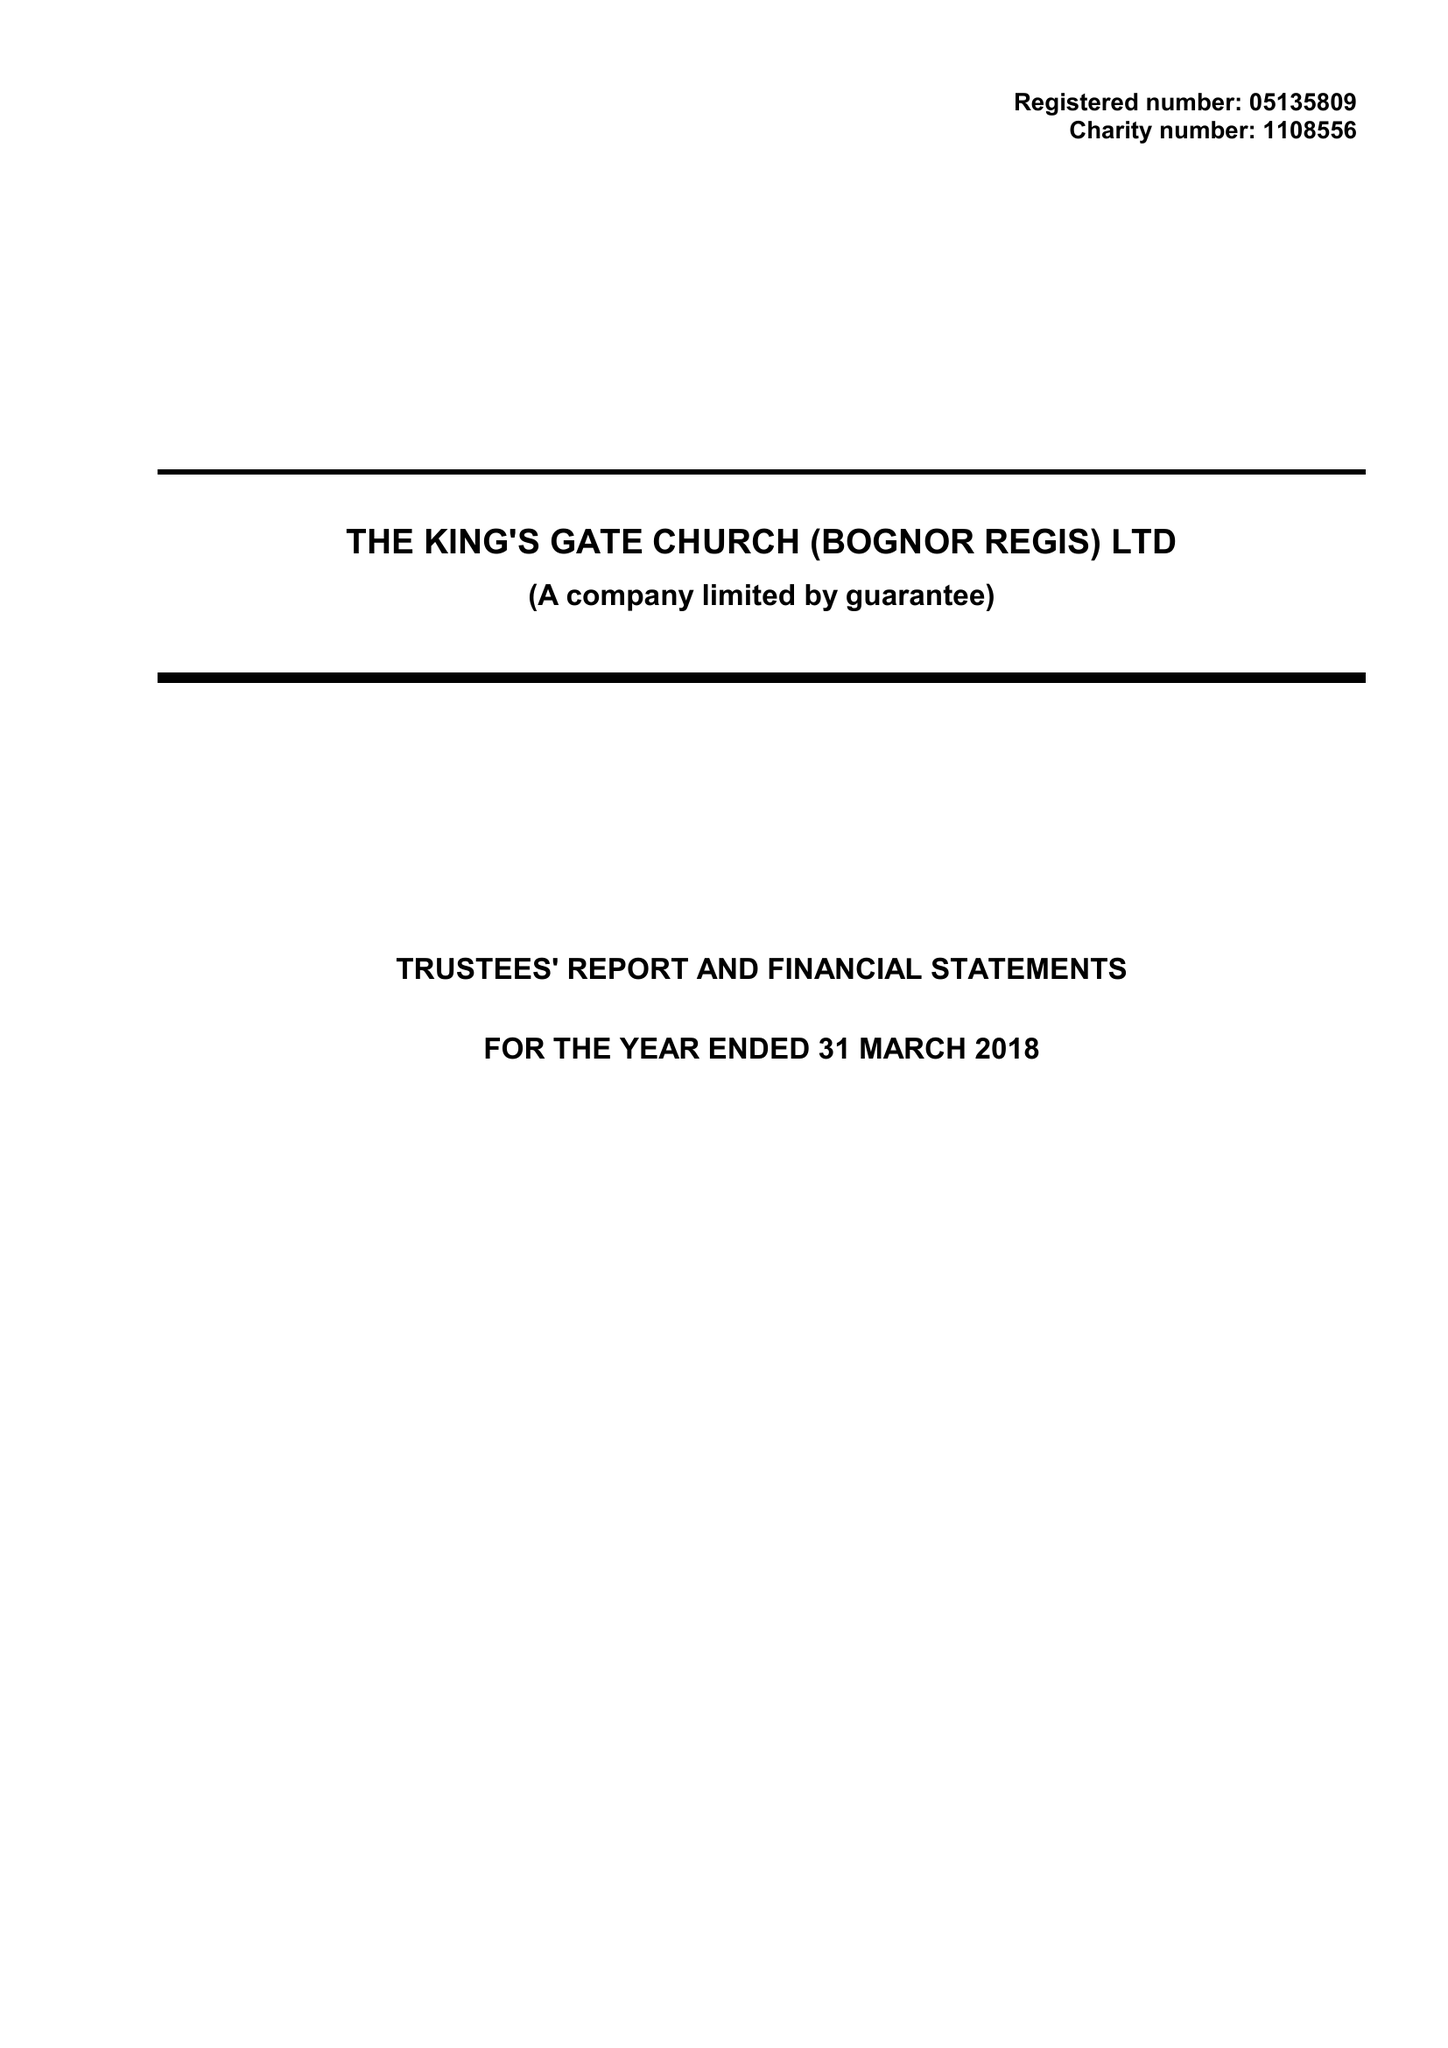What is the value for the address__post_town?
Answer the question using a single word or phrase. BOGNOR REGIS 